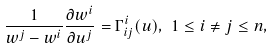Convert formula to latex. <formula><loc_0><loc_0><loc_500><loc_500>\frac { 1 } { w ^ { j } - w ^ { i } } \frac { \partial w ^ { i } } { \partial u ^ { j } } = \Gamma ^ { i } _ { i j } ( u ) , \ 1 \leq i \neq j \leq n ,</formula> 